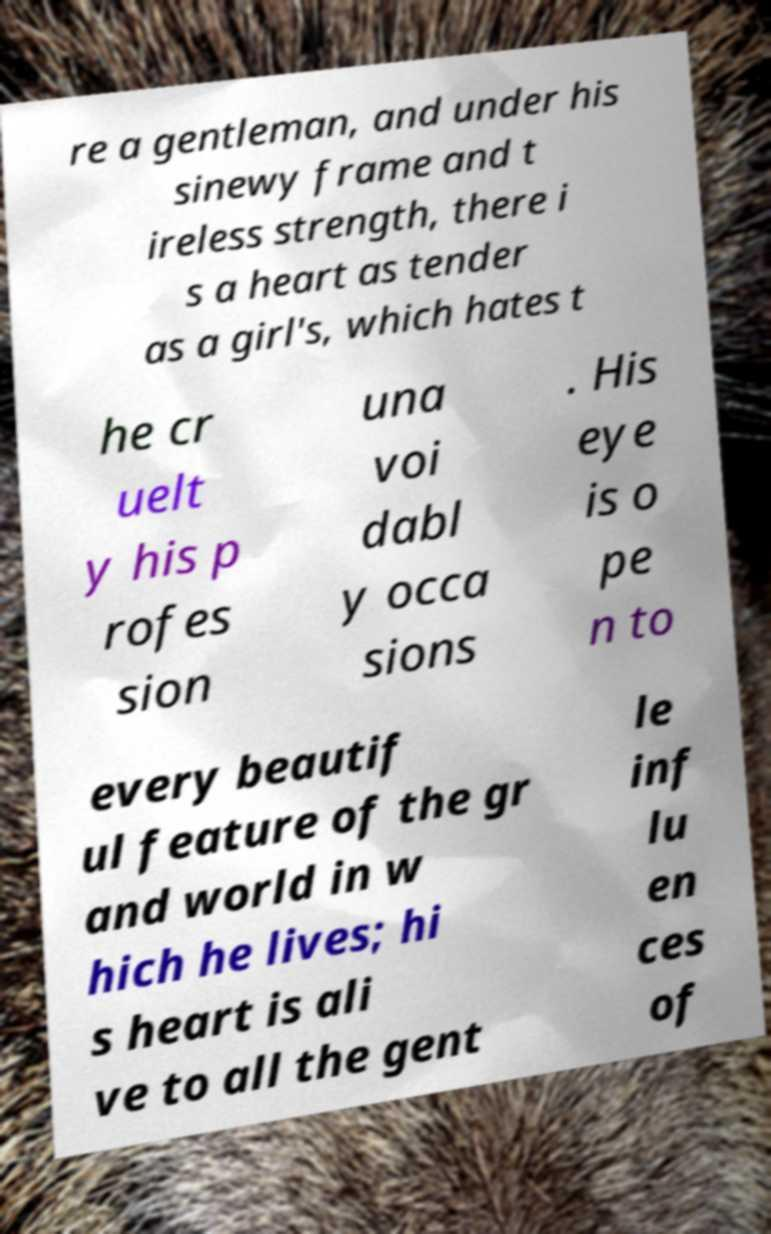Can you read and provide the text displayed in the image?This photo seems to have some interesting text. Can you extract and type it out for me? re a gentleman, and under his sinewy frame and t ireless strength, there i s a heart as tender as a girl's, which hates t he cr uelt y his p rofes sion una voi dabl y occa sions . His eye is o pe n to every beautif ul feature of the gr and world in w hich he lives; hi s heart is ali ve to all the gent le inf lu en ces of 